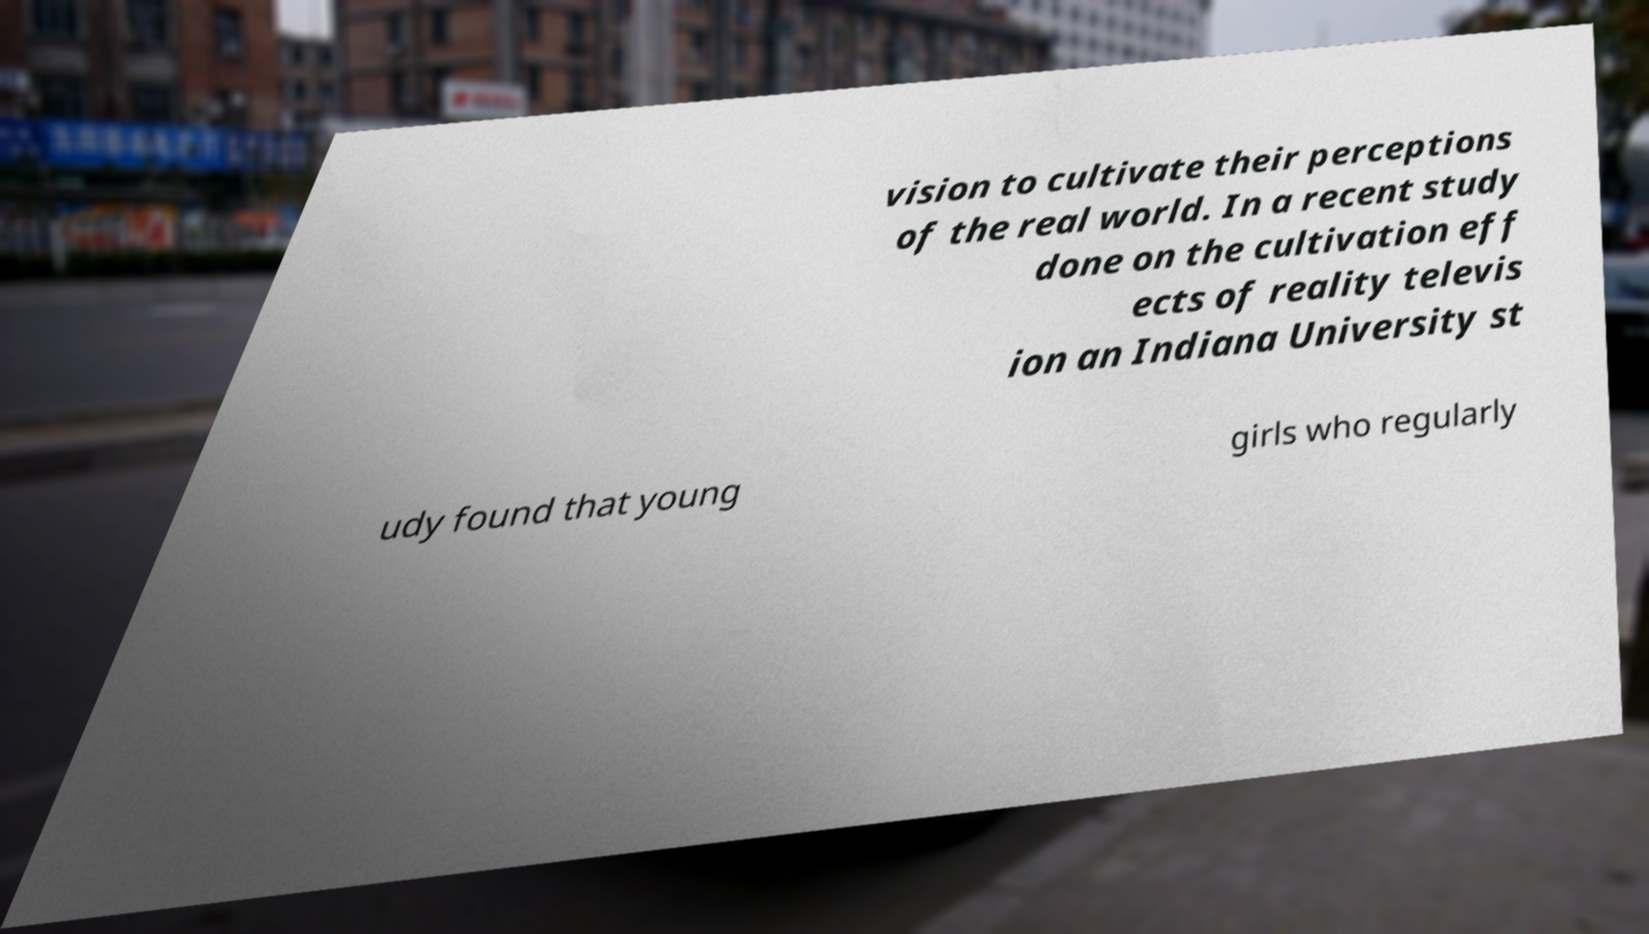Please identify and transcribe the text found in this image. vision to cultivate their perceptions of the real world. In a recent study done on the cultivation eff ects of reality televis ion an Indiana University st udy found that young girls who regularly 